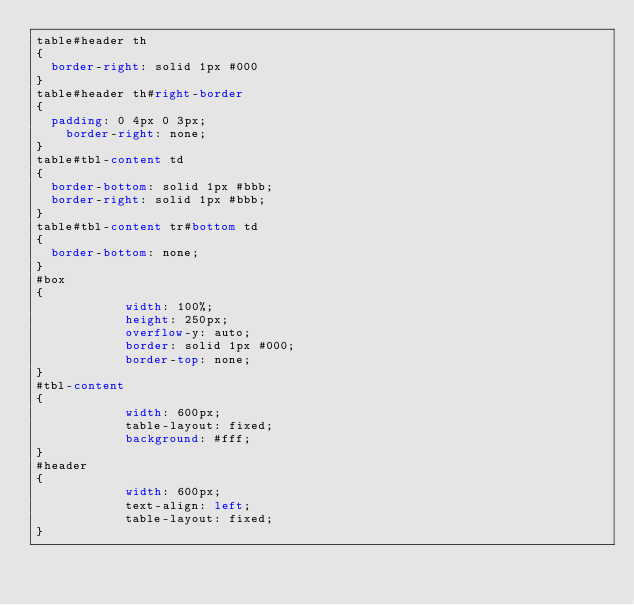Convert code to text. <code><loc_0><loc_0><loc_500><loc_500><_CSS_>table#header th
{
	border-right: solid 1px #000
}
table#header th#right-border
{
	padding: 0 4px 0 3px;
    border-right: none;
}
table#tbl-content td
{
	border-bottom: solid 1px #bbb;
	border-right: solid 1px #bbb;
}
table#tbl-content tr#bottom td
{
	border-bottom: none;
}
#box
{
            width: 100%;
            height: 250px;
            overflow-y: auto;
            border: solid 1px #000;
            border-top: none;
}
#tbl-content
{
            width: 600px;
            table-layout: fixed;
            background: #fff;
}
#header
{
            width: 600px;
            text-align: left;
            table-layout: fixed;
}
</code> 